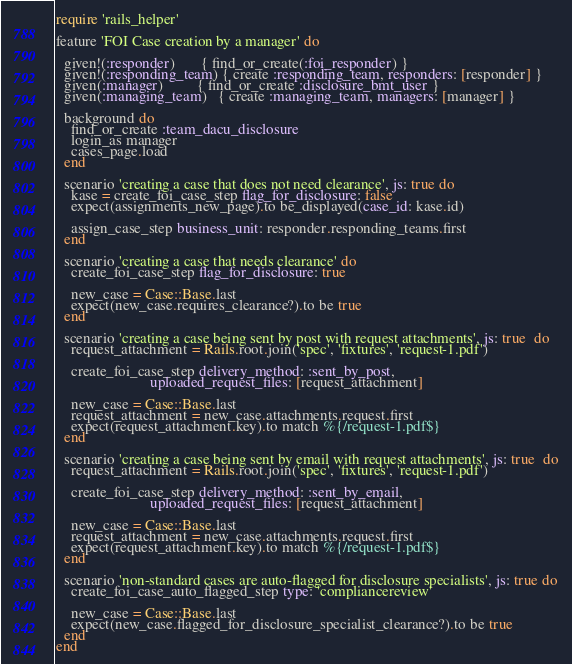Convert code to text. <code><loc_0><loc_0><loc_500><loc_500><_Ruby_>require 'rails_helper'

feature 'FOI Case creation by a manager' do

  given!(:responder)       { find_or_create(:foi_responder) }
  given!(:responding_team) { create :responding_team, responders: [responder] }
  given(:manager)         { find_or_create :disclosure_bmt_user }
  given(:managing_team)   { create :managing_team, managers: [manager] }

  background do
    find_or_create :team_dacu_disclosure
    login_as manager
    cases_page.load
  end

  scenario 'creating a case that does not need clearance', js: true do
    kase = create_foi_case_step flag_for_disclosure: false
    expect(assignments_new_page).to be_displayed(case_id: kase.id)

    assign_case_step business_unit: responder.responding_teams.first
  end

  scenario 'creating a case that needs clearance' do
    create_foi_case_step flag_for_disclosure: true

    new_case = Case::Base.last
    expect(new_case.requires_clearance?).to be true
  end

  scenario 'creating a case being sent by post with request attachments', js: true  do
    request_attachment = Rails.root.join('spec', 'fixtures', 'request-1.pdf')

    create_foi_case_step delivery_method: :sent_by_post,
                         uploaded_request_files: [request_attachment]

    new_case = Case::Base.last
    request_attachment = new_case.attachments.request.first
    expect(request_attachment.key).to match %{/request-1.pdf$}
  end

  scenario 'creating a case being sent by email with request attachments', js: true  do
    request_attachment = Rails.root.join('spec', 'fixtures', 'request-1.pdf')

    create_foi_case_step delivery_method: :sent_by_email,
                         uploaded_request_files: [request_attachment]

    new_case = Case::Base.last
    request_attachment = new_case.attachments.request.first
    expect(request_attachment.key).to match %{/request-1.pdf$}
  end

  scenario 'non-standard cases are auto-flagged for disclosure specialists', js: true do
    create_foi_case_auto_flagged_step type: 'compliancereview'

    new_case = Case::Base.last
    expect(new_case.flagged_for_disclosure_specialist_clearance?).to be true
  end
end
</code> 